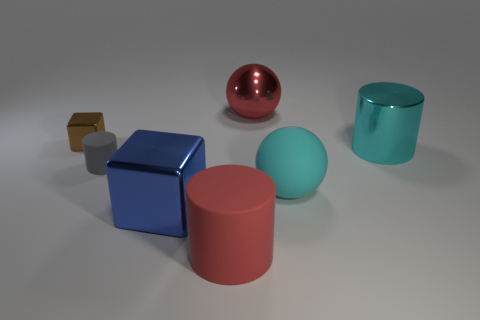There is a cube that is the same size as the cyan metallic object; what material is it?
Offer a terse response. Metal. How many objects are either tiny brown shiny cubes or cyan rubber balls?
Provide a short and direct response. 2. What number of metal objects are left of the red matte cylinder and behind the brown metallic object?
Offer a terse response. 0. Is the number of small blocks right of the large red shiny object less than the number of big yellow balls?
Keep it short and to the point. No. There is a brown object that is the same size as the gray thing; what shape is it?
Ensure brevity in your answer.  Cube. How many other objects are there of the same color as the matte sphere?
Your answer should be compact. 1. Do the cyan rubber object and the blue cube have the same size?
Your answer should be very brief. Yes. What number of objects are shiny things or cylinders in front of the big cube?
Offer a very short reply. 5. Are there fewer big objects that are behind the gray object than big things that are in front of the red metallic thing?
Offer a very short reply. Yes. How many other objects are the same material as the blue object?
Keep it short and to the point. 3. 